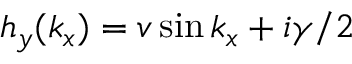Convert formula to latex. <formula><loc_0><loc_0><loc_500><loc_500>h _ { y } ( k _ { x } ) = v \sin k _ { x } + i \gamma / 2</formula> 